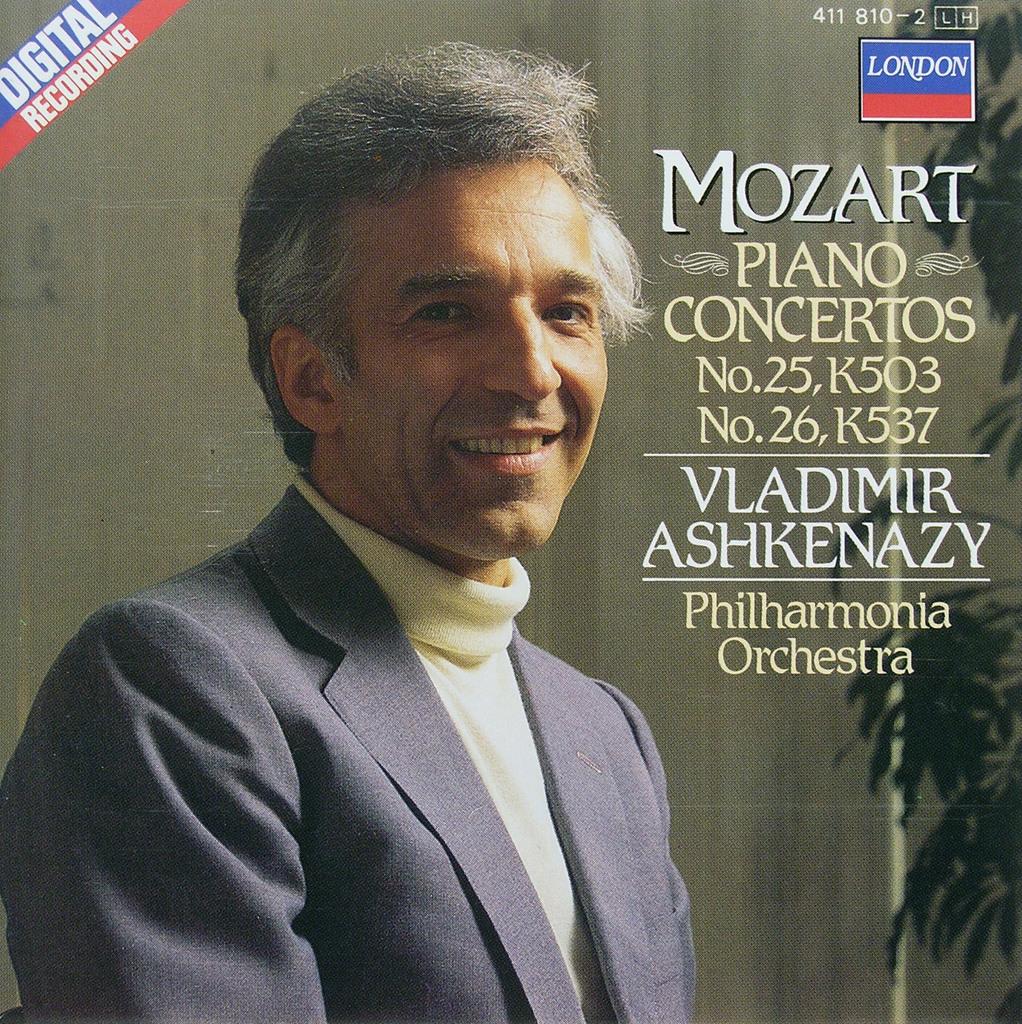Who put out this album?
Your answer should be compact. Vladimir ashkenazy. 